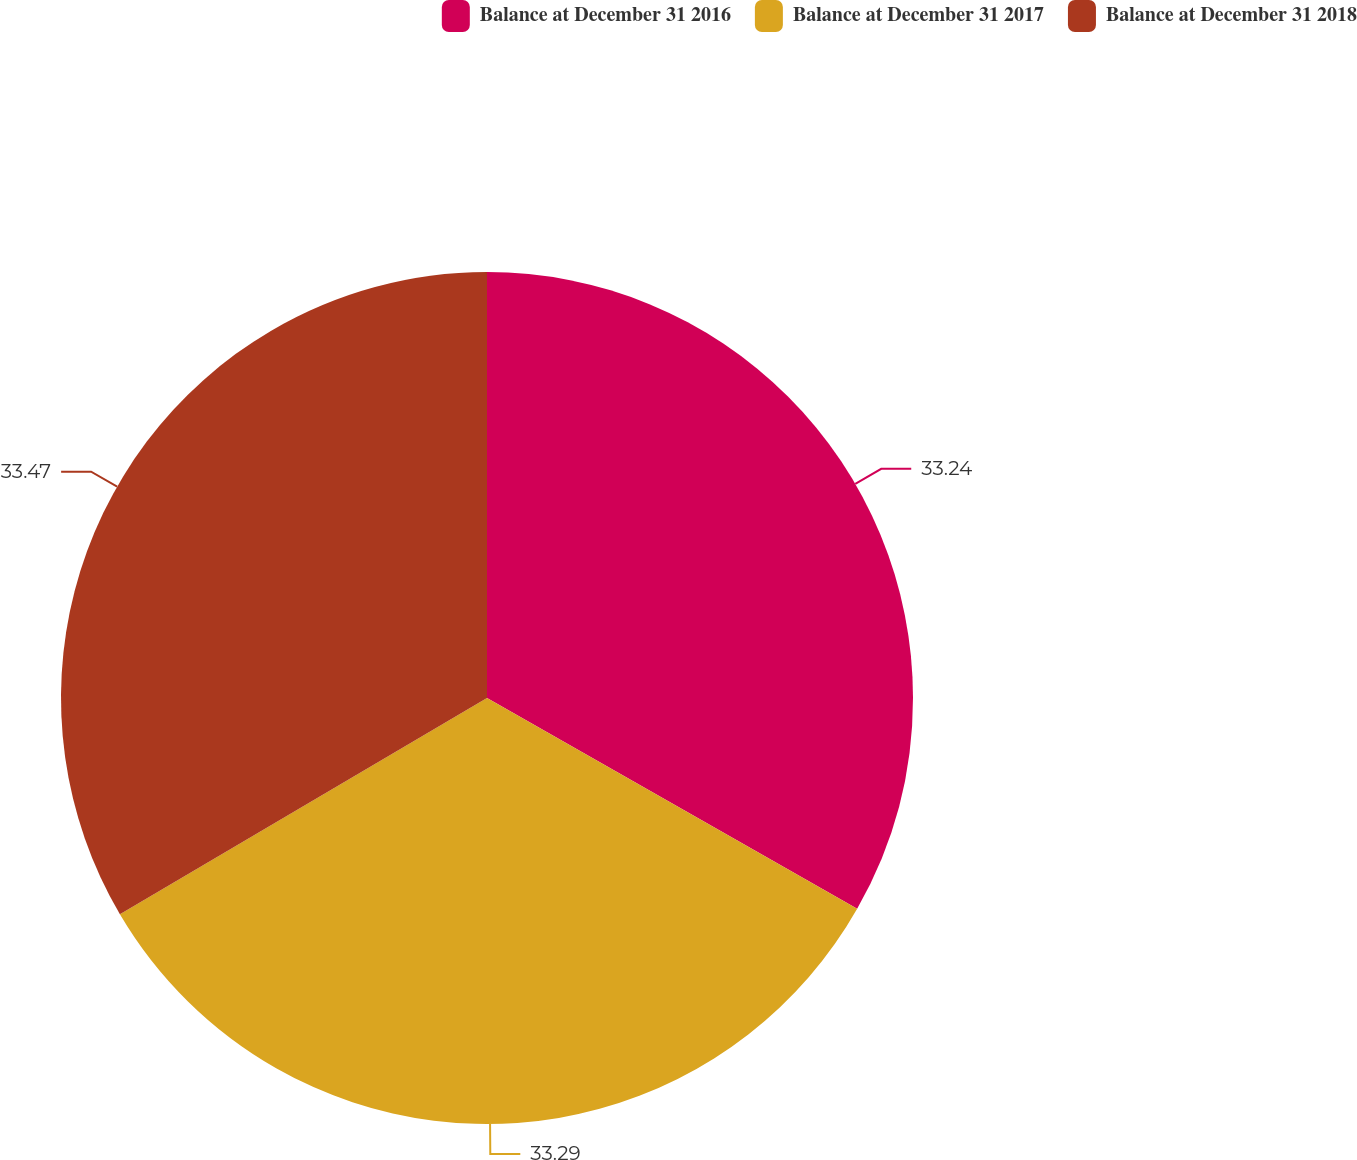<chart> <loc_0><loc_0><loc_500><loc_500><pie_chart><fcel>Balance at December 31 2016<fcel>Balance at December 31 2017<fcel>Balance at December 31 2018<nl><fcel>33.24%<fcel>33.29%<fcel>33.47%<nl></chart> 